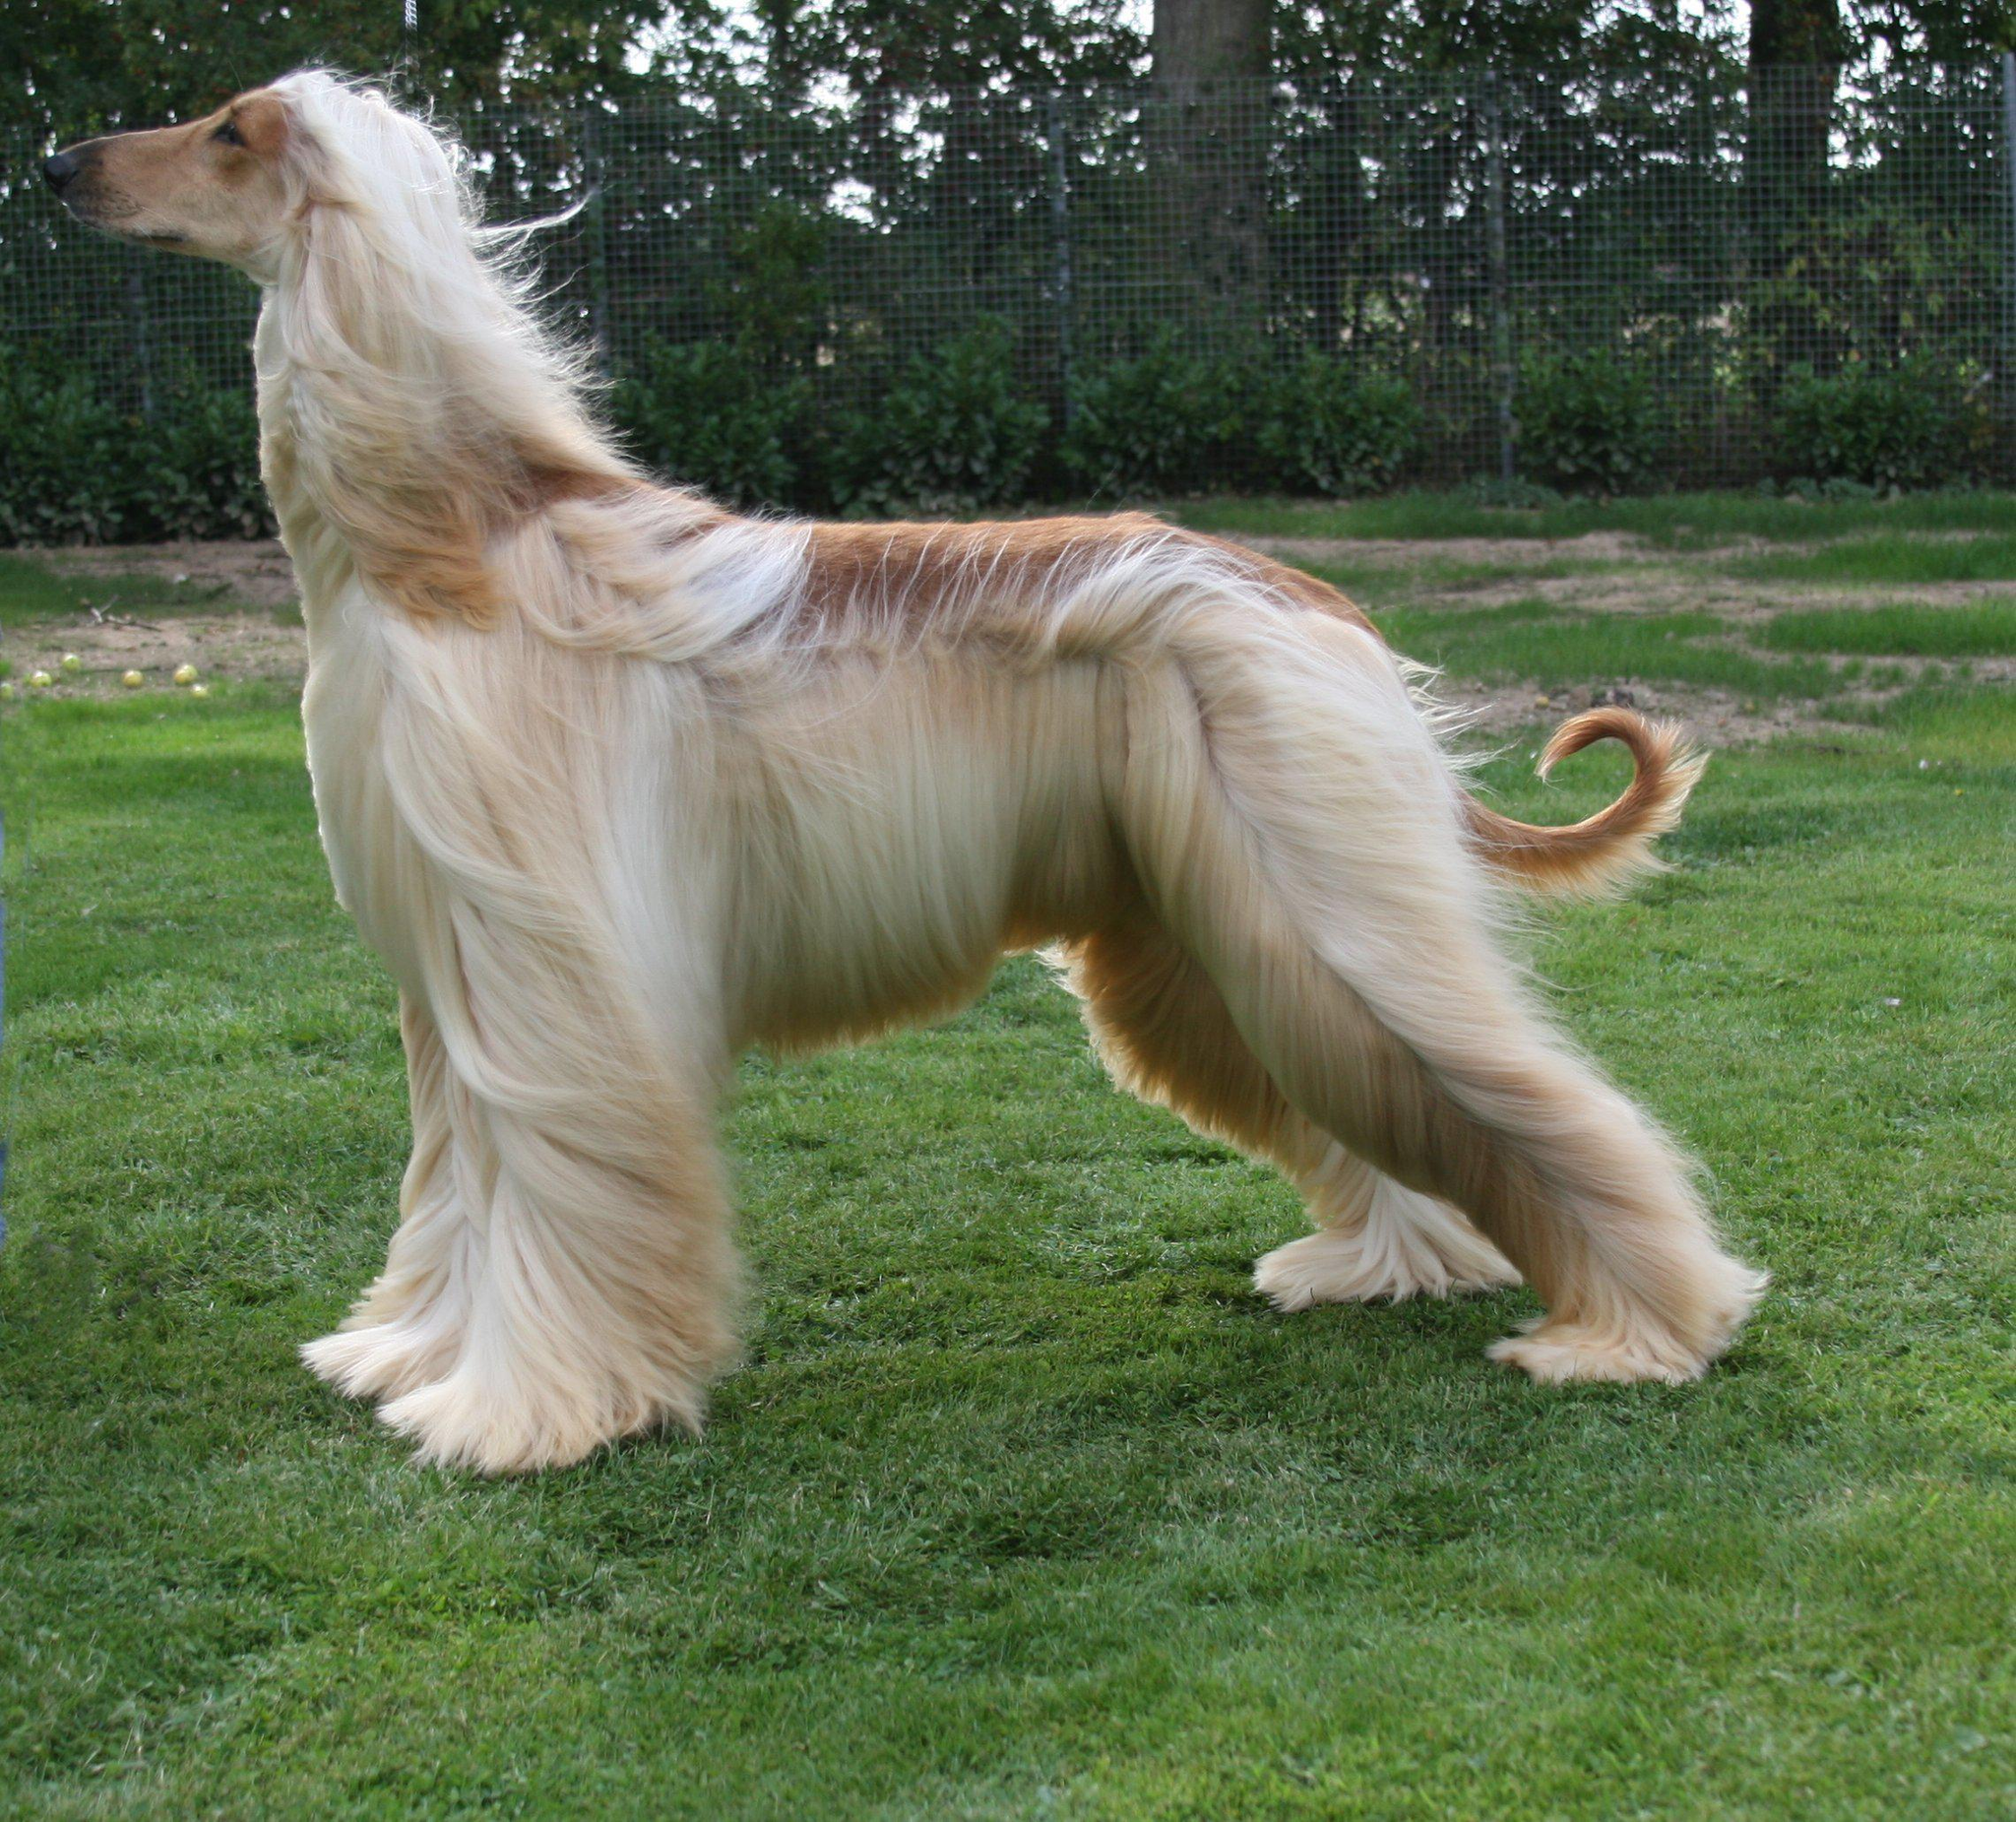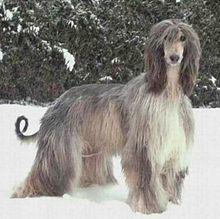The first image is the image on the left, the second image is the image on the right. Given the left and right images, does the statement "The bodies of the dogs in the paired images are turned in the same direction." hold true? Answer yes or no. No. 